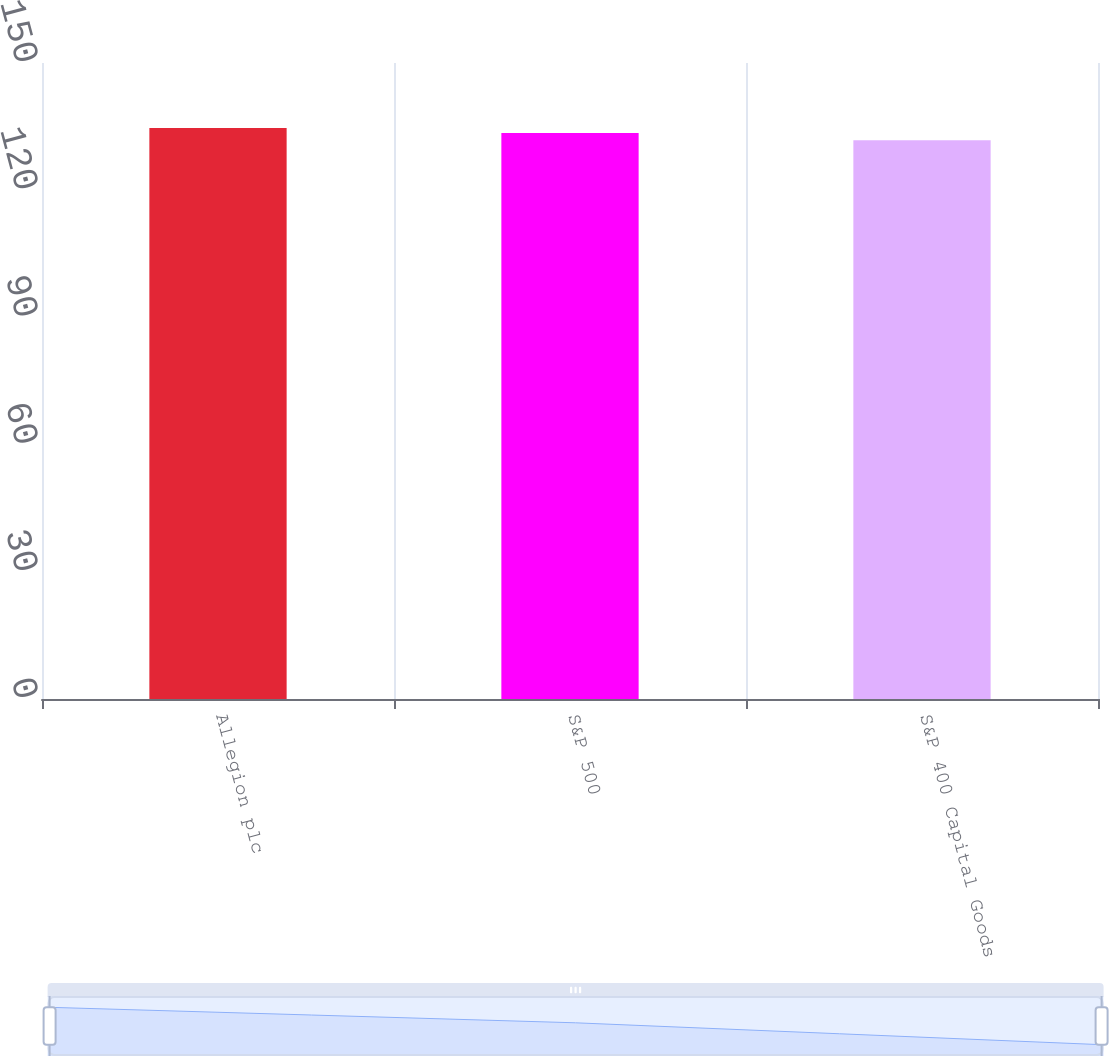Convert chart. <chart><loc_0><loc_0><loc_500><loc_500><bar_chart><fcel>Allegion plc<fcel>S&P 500<fcel>S&P 400 Capital Goods<nl><fcel>134.67<fcel>133.48<fcel>131.8<nl></chart> 